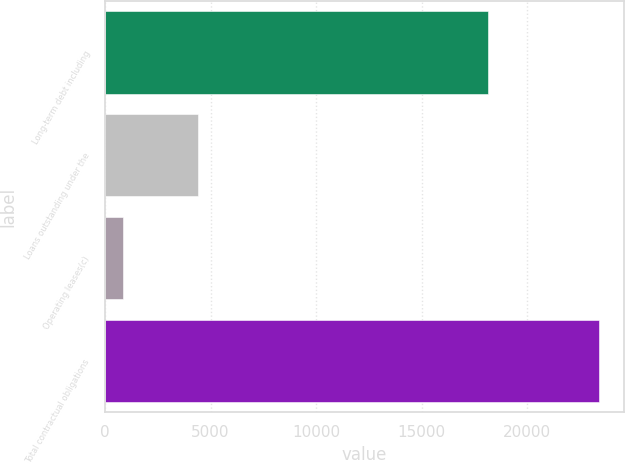Convert chart. <chart><loc_0><loc_0><loc_500><loc_500><bar_chart><fcel>Long-term debt including<fcel>Loans outstanding under the<fcel>Operating leases(c)<fcel>Total contractual obligations<nl><fcel>18145<fcel>4385<fcel>870<fcel>23400<nl></chart> 